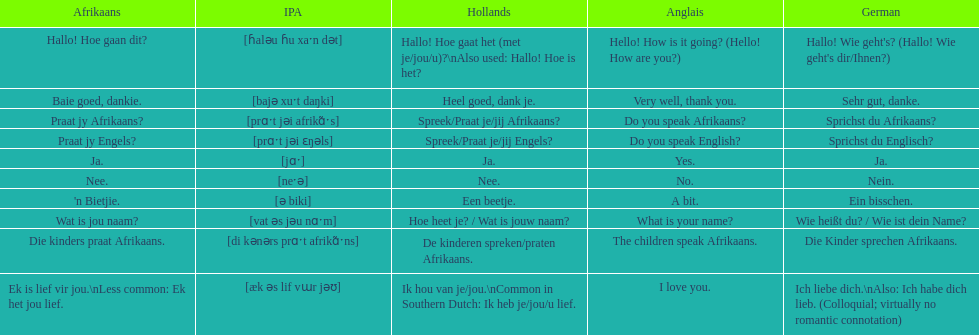How do you say "do you speak afrikaans?" in afrikaans? Praat jy Afrikaans?. 